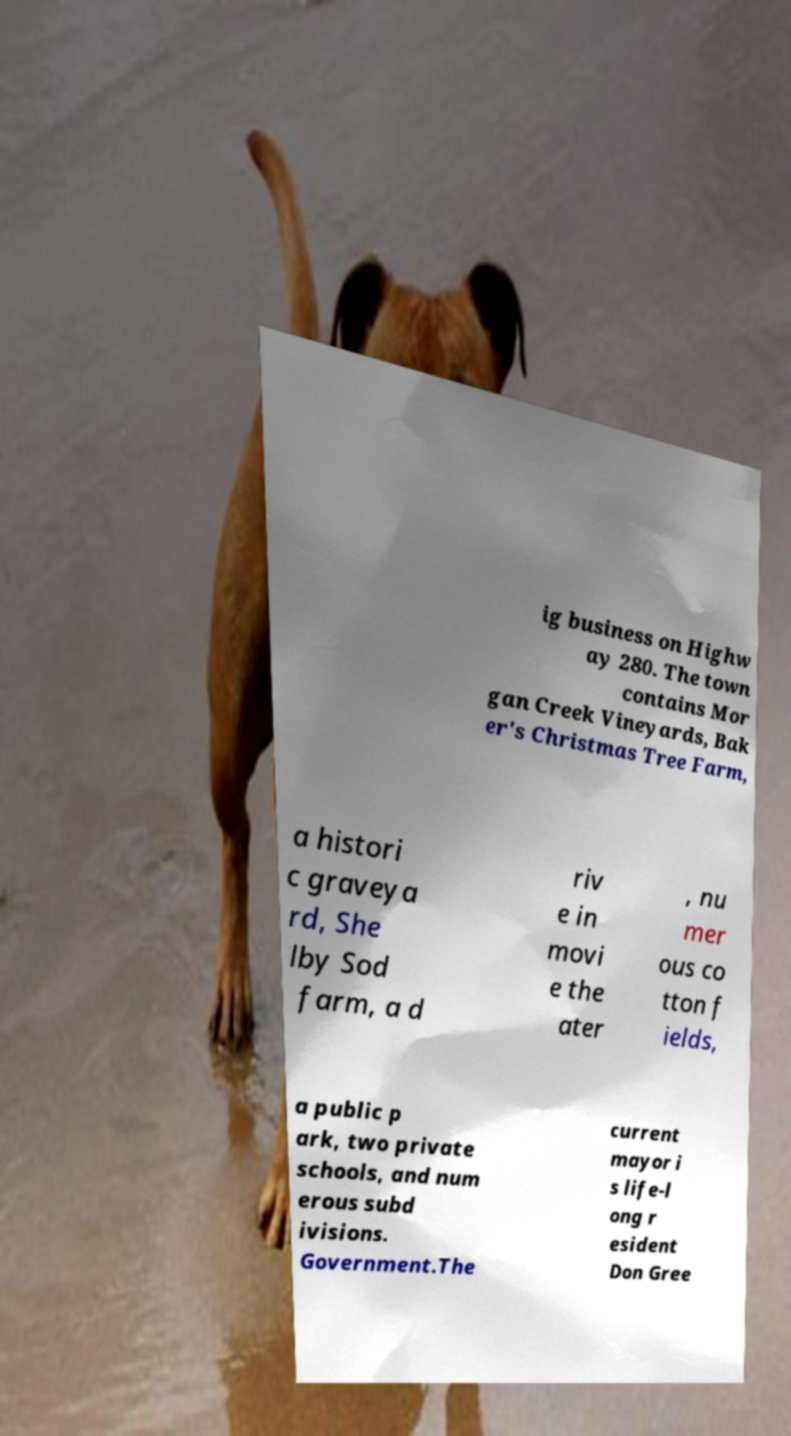Could you extract and type out the text from this image? ig business on Highw ay 280. The town contains Mor gan Creek Vineyards, Bak er's Christmas Tree Farm, a histori c graveya rd, She lby Sod farm, a d riv e in movi e the ater , nu mer ous co tton f ields, a public p ark, two private schools, and num erous subd ivisions. Government.The current mayor i s life-l ong r esident Don Gree 